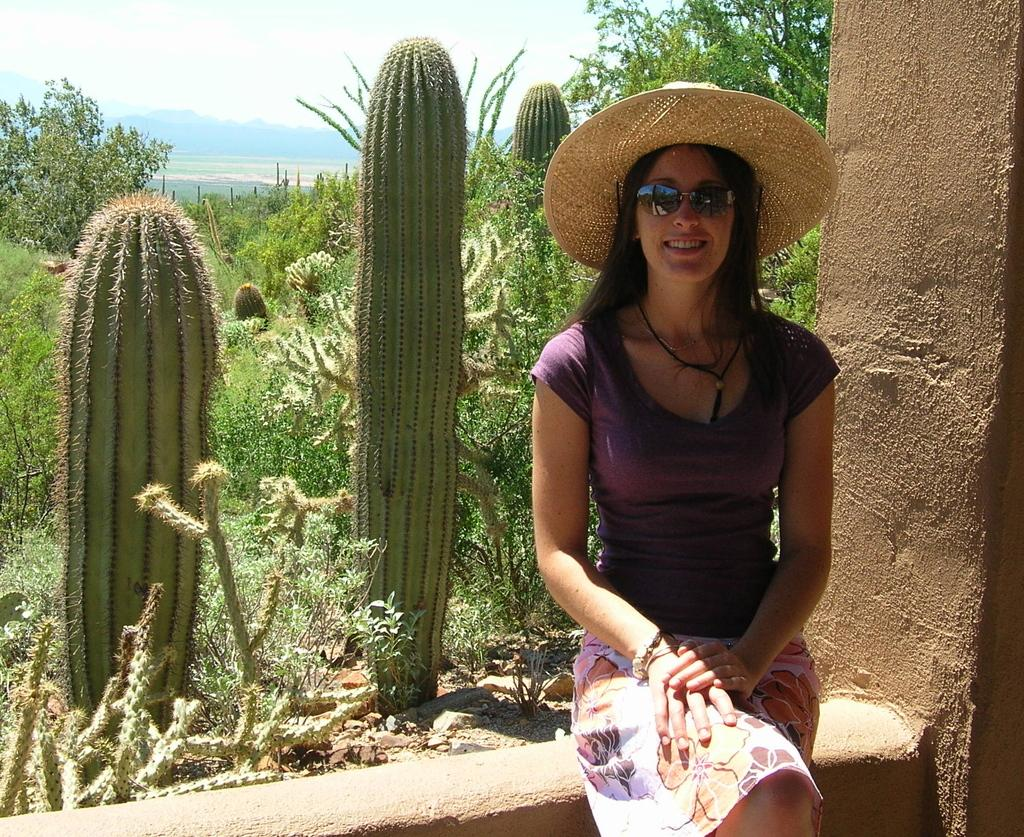Who is the main subject in the image? There is a lady in the image. Where is the lady located in the image? The lady is on the right side of the image. What is the lady wearing on her head? The lady is wearing a hat. What can be seen in the background of the image? There is greenery in the background of the image. How many tickets does the lady have in her hand in the image? There is no indication in the image that the lady is holding any tickets. 